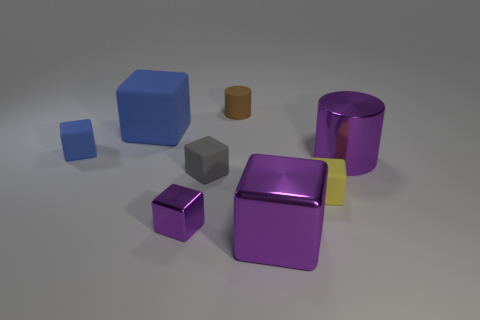Subtract all gray blocks. How many blocks are left? 5 Subtract all large purple shiny blocks. How many blocks are left? 5 Subtract all cyan cubes. Subtract all gray spheres. How many cubes are left? 6 Add 2 brown matte cylinders. How many objects exist? 10 Subtract all cubes. How many objects are left? 2 Subtract 0 yellow cylinders. How many objects are left? 8 Subtract all purple blocks. Subtract all small metal cubes. How many objects are left? 5 Add 5 large blue objects. How many large blue objects are left? 6 Add 8 gray matte objects. How many gray matte objects exist? 9 